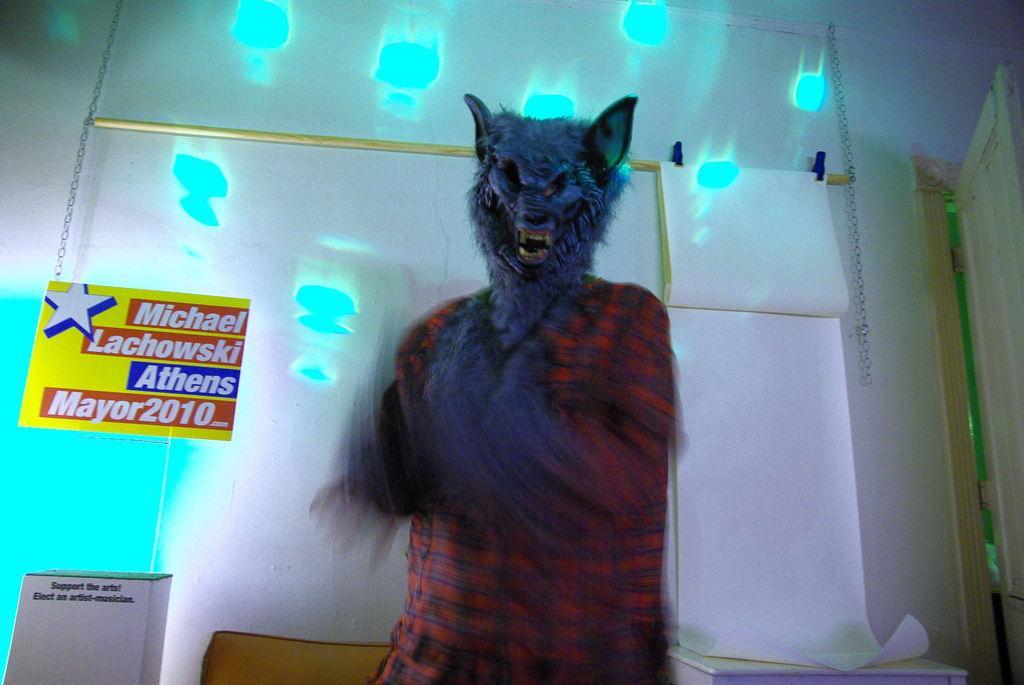Describe this image in one or two sentences. In this image there is a person wearing a mask. In the background of the image there is a wall. There is a poster. There are blue colored spots on the wall. On the right side of the image there is a door. There is a table. In the center of the image there is a wooden object. On the left side of the image there is some object with text on it. 